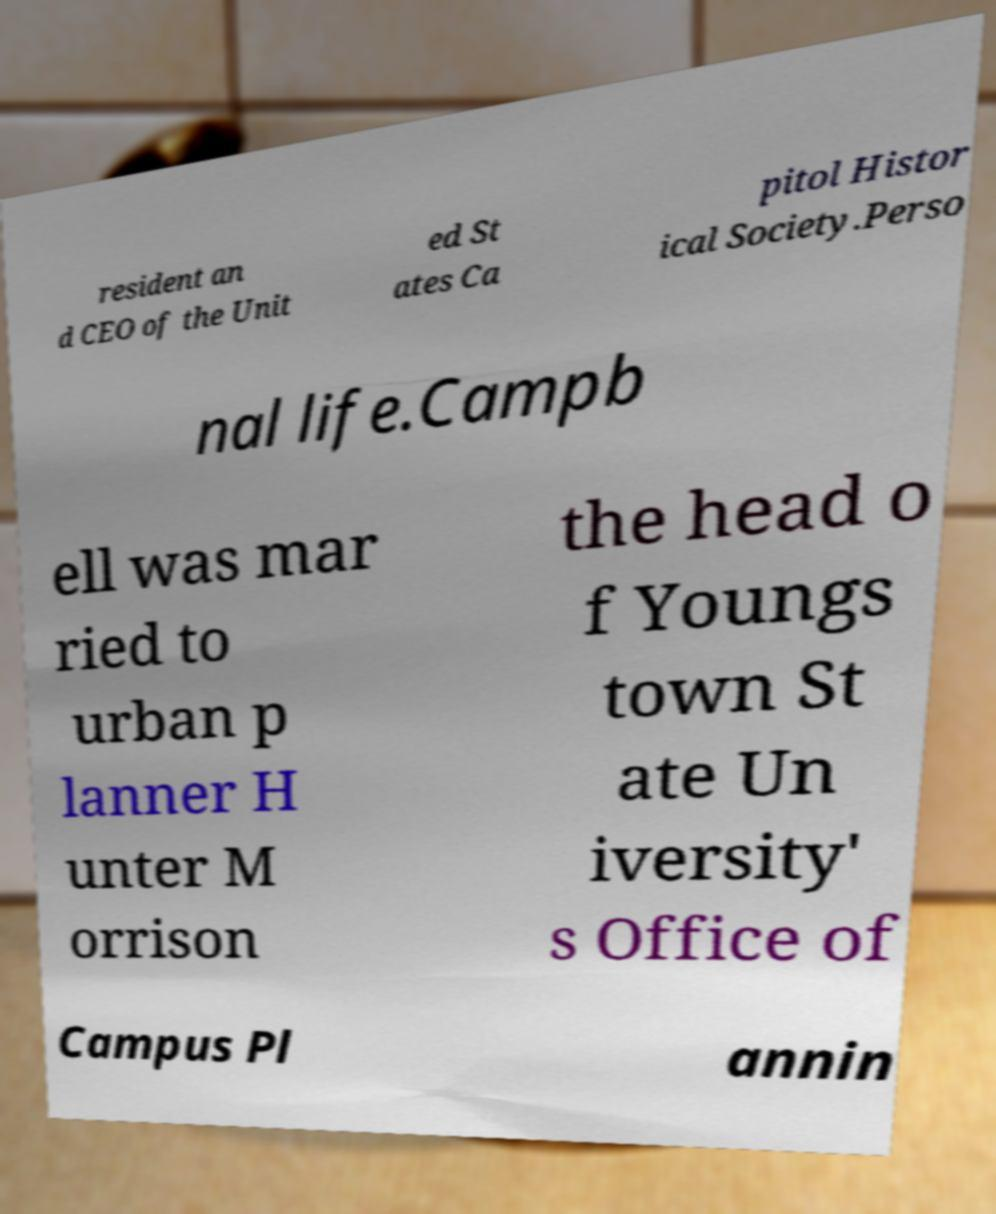Please read and relay the text visible in this image. What does it say? resident an d CEO of the Unit ed St ates Ca pitol Histor ical Society.Perso nal life.Campb ell was mar ried to urban p lanner H unter M orrison the head o f Youngs town St ate Un iversity' s Office of Campus Pl annin 